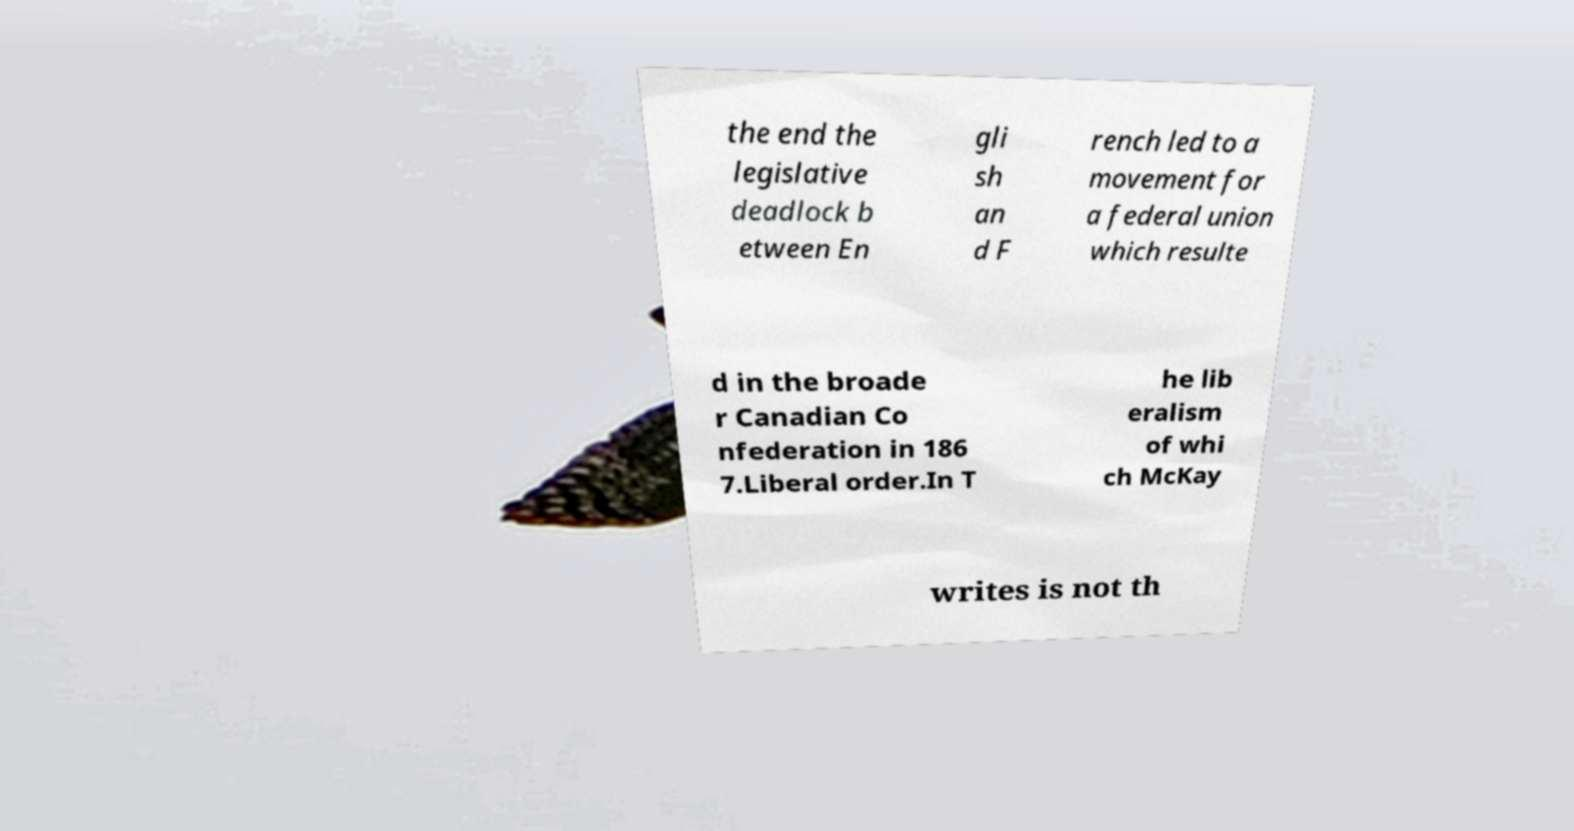Can you read and provide the text displayed in the image?This photo seems to have some interesting text. Can you extract and type it out for me? the end the legislative deadlock b etween En gli sh an d F rench led to a movement for a federal union which resulte d in the broade r Canadian Co nfederation in 186 7.Liberal order.In T he lib eralism of whi ch McKay writes is not th 